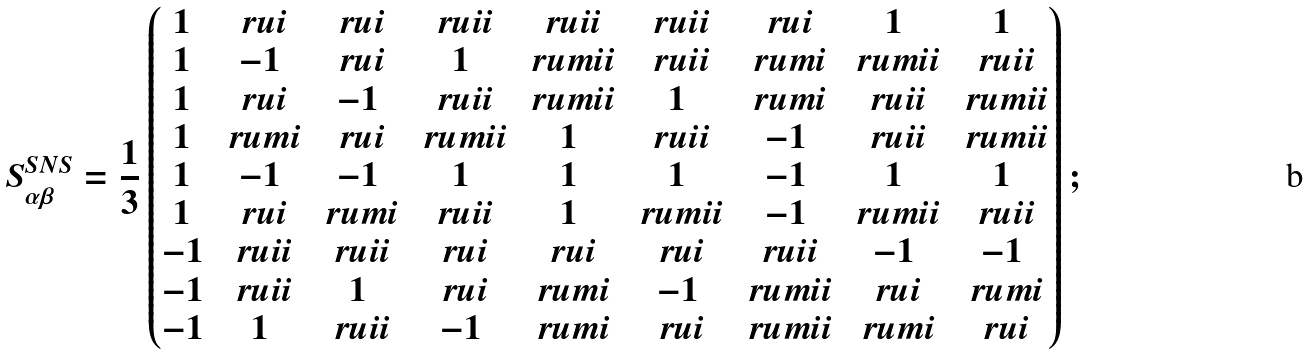<formula> <loc_0><loc_0><loc_500><loc_500>S ^ { S N S } _ { \alpha \beta } = \frac { 1 } { 3 } \begin{pmatrix} 1 & \ r u i & \ r u i & \ r u i i & \ r u i i & \ r u i i & \ r u i & 1 & 1 \\ 1 & - 1 & \ r u i & 1 & \ r u m i i & \ r u i i & \ r u m i & \ r u m i i & \ r u i i \\ 1 & \ r u i & - 1 & \ r u i i & \ r u m i i & 1 & \ r u m i & \ r u i i & \ r u m i i \\ 1 & \ r u m i & \ r u i & \ r u m i i & 1 & \ r u i i & - 1 & \ r u i i & \ r u m i i \\ 1 & - 1 & - 1 & 1 & 1 & 1 & - 1 & 1 & 1 \\ 1 & \ r u i & \ r u m i & \ r u i i & 1 & \ r u m i i & - 1 & \ r u m i i & \ r u i i \\ - 1 & \ r u i i & \ r u i i & \ r u i & \ r u i & \ r u i & \ r u i i & - 1 & - 1 \\ - 1 & \ r u i i & 1 & \ r u i & \ r u m i & - 1 & \ r u m i i & \ r u i & \ r u m i \\ - 1 & 1 & \ r u i i & - 1 & \ r u m i & \ r u i & \ r u m i i & \ r u m i & \ r u i \end{pmatrix} ;</formula> 